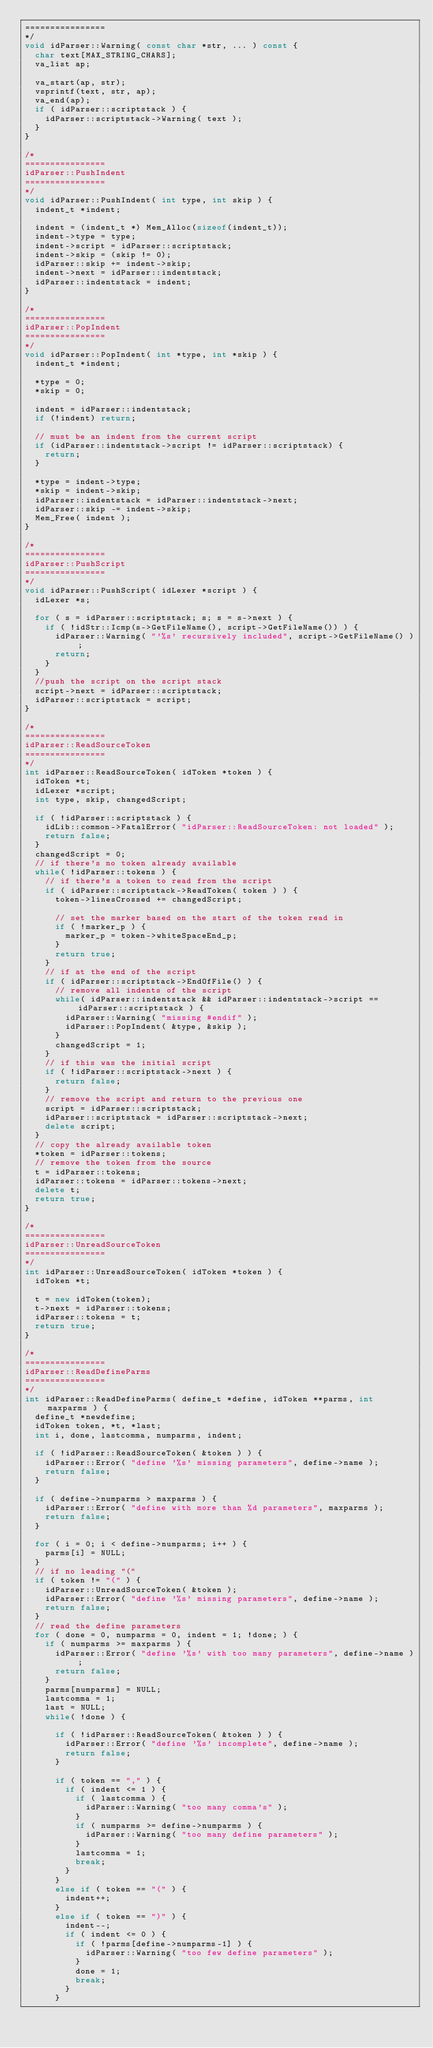Convert code to text. <code><loc_0><loc_0><loc_500><loc_500><_C++_>================
*/
void idParser::Warning( const char *str, ... ) const {
	char text[MAX_STRING_CHARS];
	va_list ap;

	va_start(ap, str);
	vsprintf(text, str, ap);
	va_end(ap);
	if ( idParser::scriptstack ) {
		idParser::scriptstack->Warning( text );
	}
}

/*
================
idParser::PushIndent
================
*/
void idParser::PushIndent( int type, int skip ) {
	indent_t *indent;

	indent = (indent_t *) Mem_Alloc(sizeof(indent_t));
	indent->type = type;
	indent->script = idParser::scriptstack;
	indent->skip = (skip != 0);
	idParser::skip += indent->skip;
	indent->next = idParser::indentstack;
	idParser::indentstack = indent;
}

/*
================
idParser::PopIndent
================
*/
void idParser::PopIndent( int *type, int *skip ) {
	indent_t *indent;

	*type = 0;
	*skip = 0;

	indent = idParser::indentstack;
	if (!indent) return;

	// must be an indent from the current script
	if (idParser::indentstack->script != idParser::scriptstack) {
		return;
	}

	*type = indent->type;
	*skip = indent->skip;
	idParser::indentstack = idParser::indentstack->next;
	idParser::skip -= indent->skip;
	Mem_Free( indent );
}

/*
================
idParser::PushScript
================
*/
void idParser::PushScript( idLexer *script ) {
	idLexer *s;

	for ( s = idParser::scriptstack; s; s = s->next ) {
		if ( !idStr::Icmp(s->GetFileName(), script->GetFileName()) ) {
			idParser::Warning( "'%s' recursively included", script->GetFileName() );
			return;
		}
	}
	//push the script on the script stack
	script->next = idParser::scriptstack;
	idParser::scriptstack = script;
}

/*
================
idParser::ReadSourceToken
================
*/
int idParser::ReadSourceToken( idToken *token ) {
	idToken *t;
	idLexer *script;
	int type, skip, changedScript;

	if ( !idParser::scriptstack ) {
		idLib::common->FatalError( "idParser::ReadSourceToken: not loaded" );
		return false;
	}
	changedScript = 0;
	// if there's no token already available
	while( !idParser::tokens ) {
		// if there's a token to read from the script
		if ( idParser::scriptstack->ReadToken( token ) ) {
			token->linesCrossed += changedScript;

			// set the marker based on the start of the token read in
			if ( !marker_p ) {
				marker_p = token->whiteSpaceEnd_p;
			}
			return true;
		}
		// if at the end of the script
		if ( idParser::scriptstack->EndOfFile() ) {
			// remove all indents of the script
			while( idParser::indentstack && idParser::indentstack->script == idParser::scriptstack ) {
				idParser::Warning( "missing #endif" );
				idParser::PopIndent( &type, &skip );
			}
			changedScript = 1;
		}
		// if this was the initial script
		if ( !idParser::scriptstack->next ) {
			return false;
		}
		// remove the script and return to the previous one
		script = idParser::scriptstack;
		idParser::scriptstack = idParser::scriptstack->next;
		delete script;
	}
	// copy the already available token
	*token = idParser::tokens;
	// remove the token from the source
	t = idParser::tokens;
	idParser::tokens = idParser::tokens->next;
	delete t;
	return true;
}

/*
================
idParser::UnreadSourceToken
================
*/
int idParser::UnreadSourceToken( idToken *token ) {
	idToken *t;

	t = new idToken(token);
	t->next = idParser::tokens;
	idParser::tokens = t;
	return true;
}

/*
================
idParser::ReadDefineParms
================
*/
int idParser::ReadDefineParms( define_t *define, idToken **parms, int maxparms ) {
	define_t *newdefine;
	idToken token, *t, *last;
	int i, done, lastcomma, numparms, indent;

	if ( !idParser::ReadSourceToken( &token ) ) {
		idParser::Error( "define '%s' missing parameters", define->name );
		return false;
	}

	if ( define->numparms > maxparms ) {
		idParser::Error( "define with more than %d parameters", maxparms );
		return false;
	}

	for ( i = 0; i < define->numparms; i++ ) {
		parms[i] = NULL;
	}
	// if no leading "("
	if ( token != "(" ) {
		idParser::UnreadSourceToken( &token );
		idParser::Error( "define '%s' missing parameters", define->name );
		return false;
	}
	// read the define parameters
	for ( done = 0, numparms = 0, indent = 1; !done; ) {
		if ( numparms >= maxparms ) {
			idParser::Error( "define '%s' with too many parameters", define->name );
			return false;
		}
		parms[numparms] = NULL;
		lastcomma = 1;
		last = NULL;
		while( !done ) {

			if ( !idParser::ReadSourceToken( &token ) ) {
				idParser::Error( "define '%s' incomplete", define->name );
				return false;
			}

			if ( token == "," ) {
				if ( indent <= 1 ) {
					if ( lastcomma ) {
						idParser::Warning( "too many comma's" );
					}
					if ( numparms >= define->numparms ) {
						idParser::Warning( "too many define parameters" );
					}
					lastcomma = 1;
					break;
				}
			}
			else if ( token == "(" ) {
				indent++;
			}
			else if ( token == ")" ) {
				indent--;
				if ( indent <= 0 ) {
					if ( !parms[define->numparms-1] ) {
						idParser::Warning( "too few define parameters" );
					}
					done = 1;
					break;
				}
			}</code> 